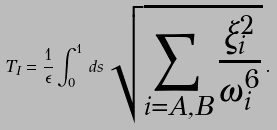<formula> <loc_0><loc_0><loc_500><loc_500>T _ { I } = \frac { 1 } { \epsilon } \int _ { 0 } ^ { 1 } \, d s \, \sqrt { \sum _ { i = A , B } \frac { \xi _ { i } ^ { 2 } } { \omega _ { i } ^ { 6 } } } \, .</formula> 